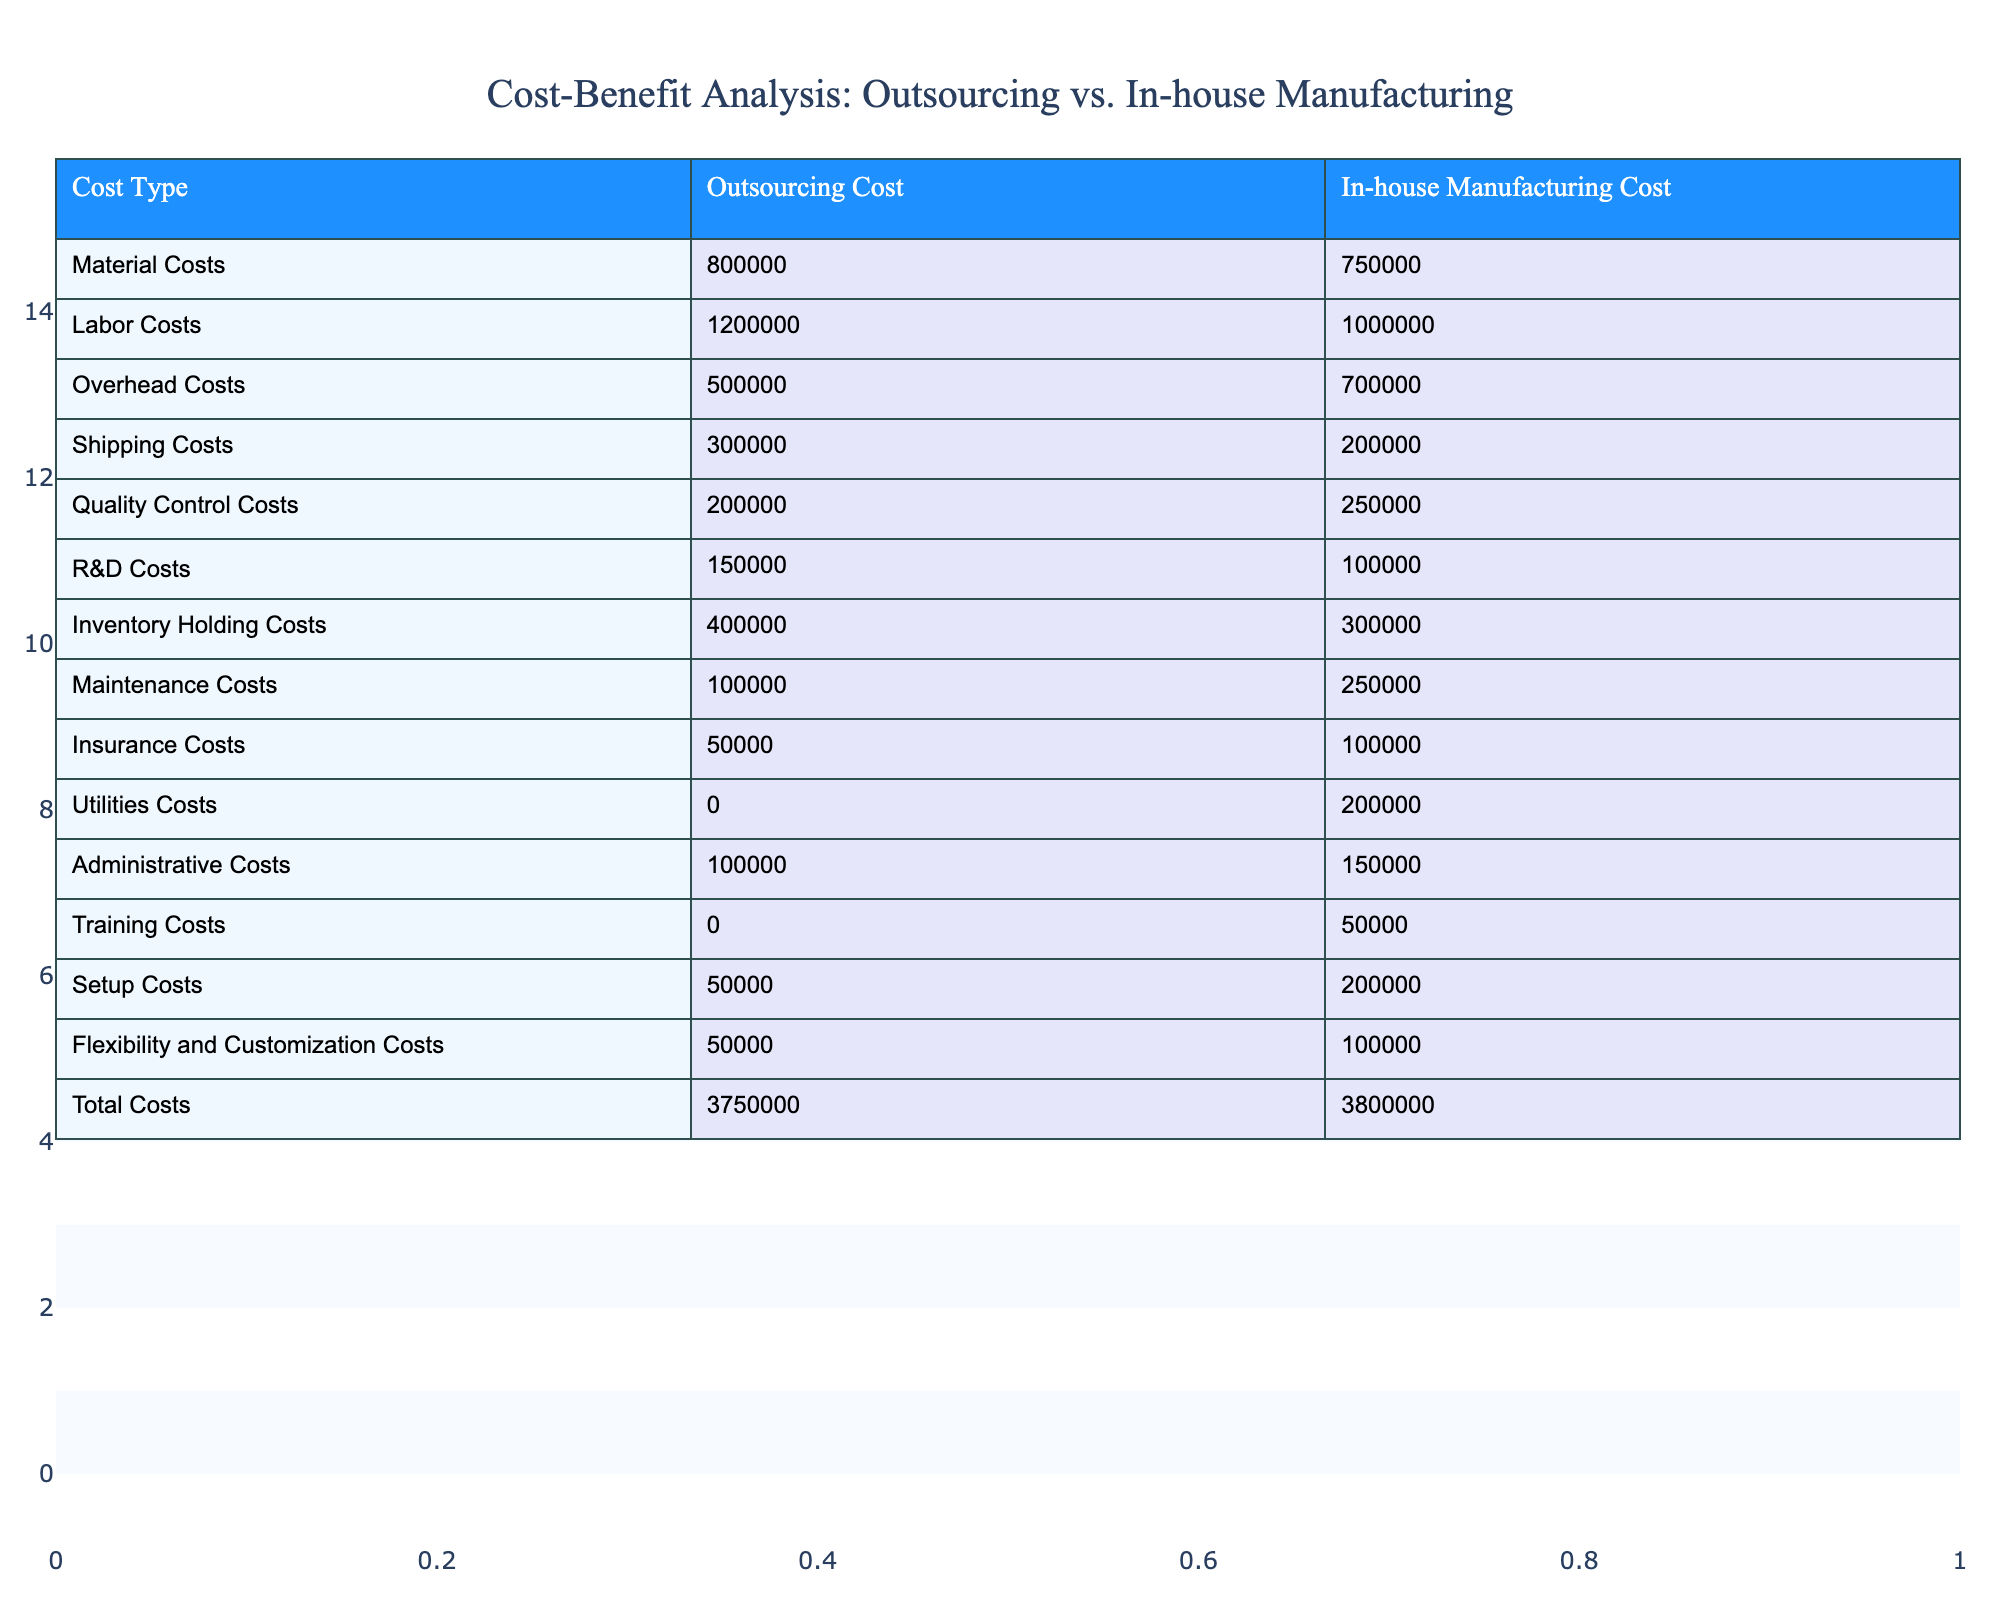What is the total Outsourcing Cost? To find the total Outsourcing Cost, we sum up all the Outsourcing Cost values in the table: Material Costs (800000) + Labor Costs (1200000) + Overhead Costs (500000) + Shipping Costs (300000) + Quality Control Costs (200000) + R&D Costs (150000) + Inventory Holding Costs (400000) + Maintenance Costs (100000) + Insurance Costs (50000) + Utilities Costs (0) + Administrative Costs (100000) + Training Costs (0) + Setup Costs (50000) + Flexibility and Customization Costs (50000) = 3750000.
Answer: 3750000 What is the difference in Labor Costs between In-house and Outsourcing? The Labor Cost for Outsourcing is 1200000, while for In-house it is 1000000. The difference is calculated as 1200000 - 1000000 = 200000.
Answer: 200000 Are Quality Control Costs higher for Outsourcing than for In-house? The Quality Control Costs for Outsourcing are 200000 and for In-house are 250000. 200000 is not greater than 250000, so the statement is false.
Answer: No What is the total of Shipping and Insurance Costs for In-house Manufacturing? For In-house Manufacturing, the Shipping Costs are 200000 and Insurance Costs are 100000. Summing these gives us 200000 + 100000 = 300000.
Answer: 300000 Which cost type has the highest difference between Outsourcing and In-house Manufacturing? To find the highest difference, we calculate the differences for each cost type. The highest difference occurs in Labor Costs, where the difference is 1200000 - 1000000 = 200000. Comparing the differences, Labor Costs have the maximum difference.
Answer: Labor Costs What is the average total cost across both production methods? We first find the total costs: Outsourcing Total (3750000) and In-house Total (3800000). The average of the two totals is (3750000 + 3800000) / 2 = 3775000.
Answer: 3775000 Is the total cost of Outsourcing less than that of In-house Manufacturing? The total cost for Outsourcing is 3750000 and for In-house is 3800000. Since 3750000 is less than 3800000, the statement is true.
Answer: Yes What is the total cost of Maintenance and Administrative Costs for Outsourcing? The Maintenance Cost is 100000 and the Administrative Cost is 100000 for Outsourcing. Adding these two amounts gives us 100000 + 100000 = 200000.
Answer: 200000 What is the combined total of Overhead Costs in both Outsourcing and In-house Manufacturing? Overhead Costs for Outsourcing are 500000 and for In-house are 700000. The combined total is calculated as 500000 + 700000 = 1200000.
Answer: 1200000 